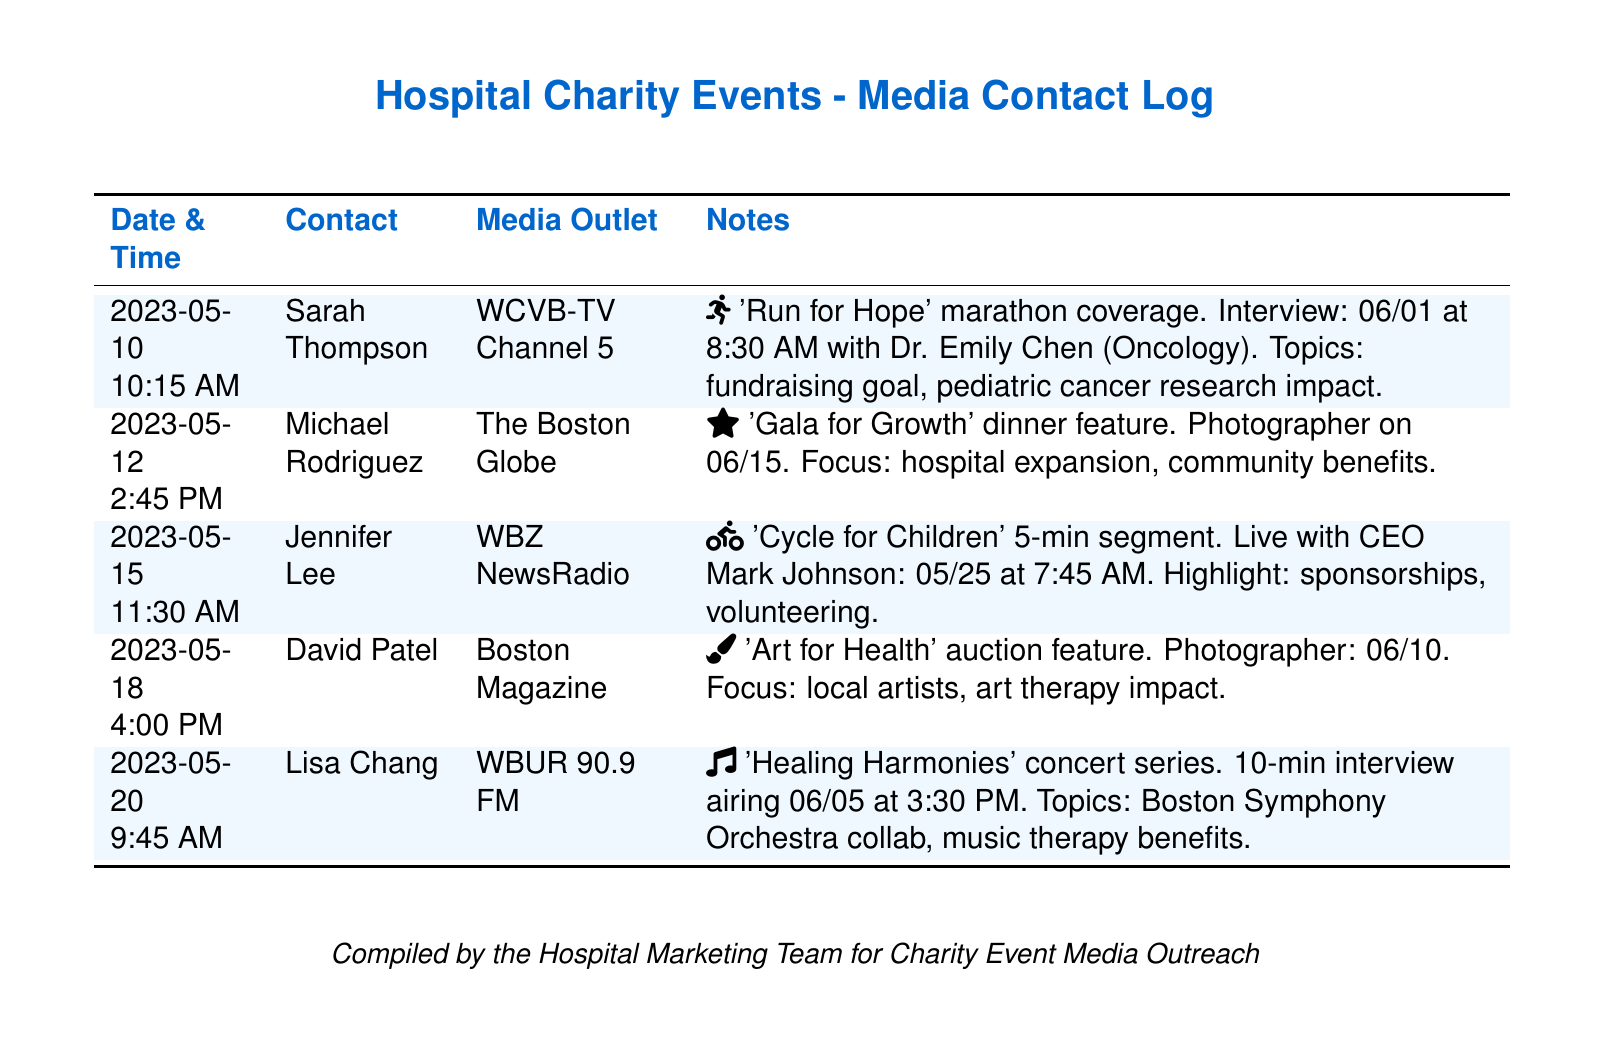What is the date of the interview with Dr. Emily Chen? The interview with Dr. Emily Chen is scheduled for 06/01, as noted in the document.
Answer: 06/01 Who is the media contact for the 'Cycle for Children' segment? The media contact for the 'Cycle for Children' segment is Jennifer Lee.
Answer: Jennifer Lee What time will the 'Healing Harmonies' interview air? The interview for 'Healing Harmonies' is scheduled to air at 3:30 PM on 06/05.
Answer: 3:30 PM What is the focus of the 'Gala for Growth' dinner feature? The focus of the 'Gala for Growth' is on hospital expansion and community benefits, as mentioned in the notes.
Answer: hospital expansion, community benefits How many interviews are scheduled before June 10? There are three interviews scheduled (with Dr. Emily Chen, CEO Mark Johnson, and Lisa Chang) before June 10.
Answer: 3 Which media outlet is covering the 'Run for Hope' marathon? The media outlet covering the 'Run for Hope' marathon is WCVB-TV Channel 5.
Answer: WCVB-TV Channel 5 What event will be featured in Boston Magazine? The event that will be featured in Boston Magazine is the 'Art for Health' auction.
Answer: Art for Health When is the photographer scheduled for the 'Gala for Growth'? The photographer for the 'Gala for Growth' is scheduled for 06/15 according to the meeting notes.
Answer: 06/15 Who is the CEO mentioned in the document? The CEO mentioned in the document is Mark Johnson.
Answer: Mark Johnson 